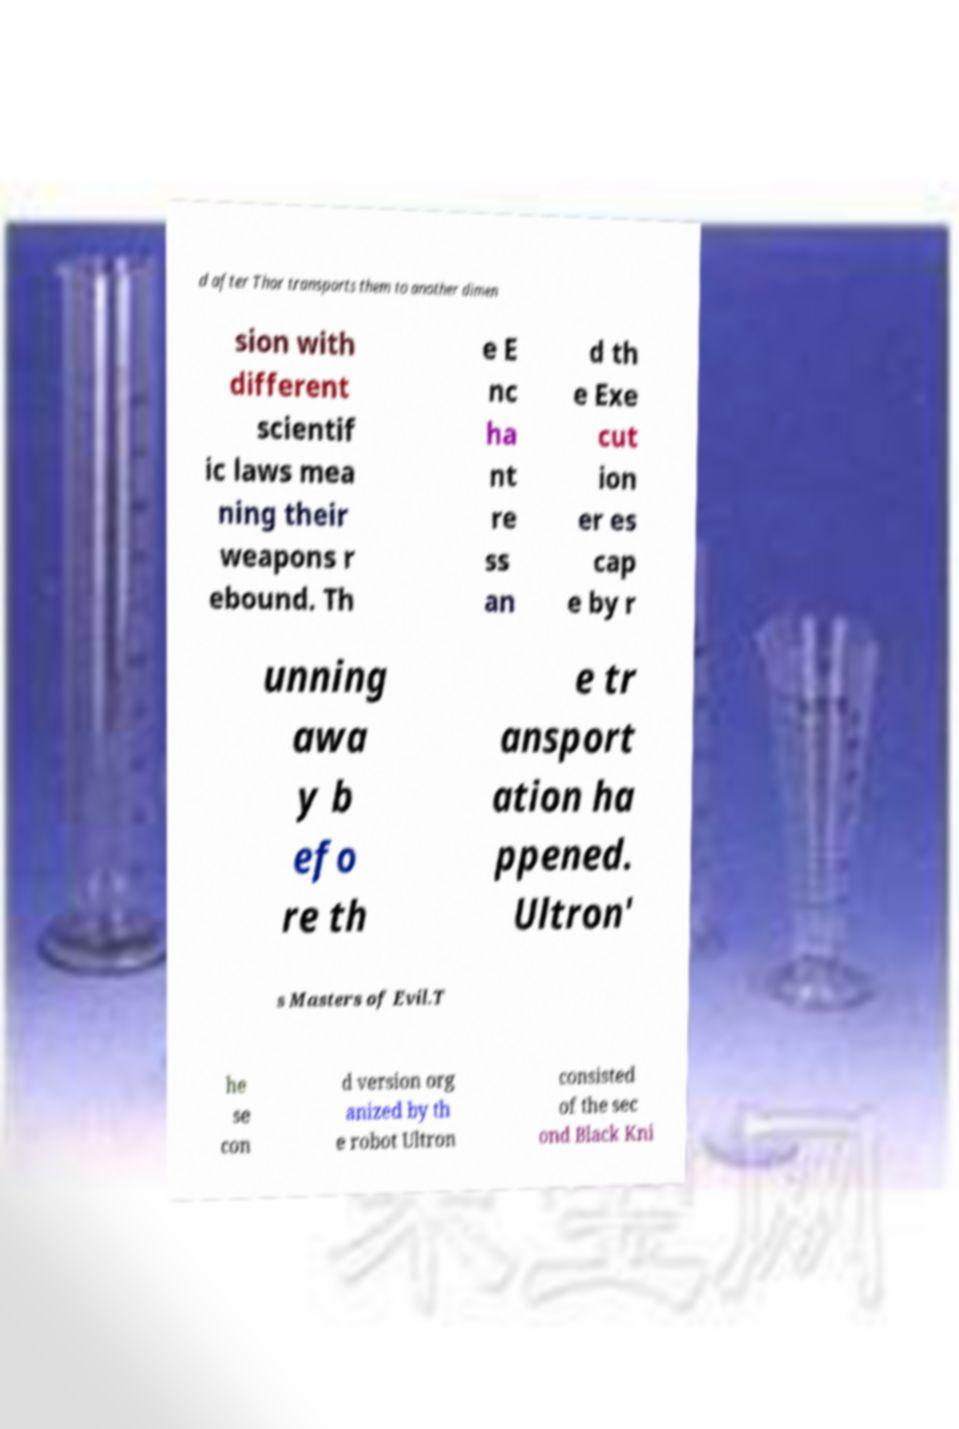What messages or text are displayed in this image? I need them in a readable, typed format. d after Thor transports them to another dimen sion with different scientif ic laws mea ning their weapons r ebound. Th e E nc ha nt re ss an d th e Exe cut ion er es cap e by r unning awa y b efo re th e tr ansport ation ha ppened. Ultron' s Masters of Evil.T he se con d version org anized by th e robot Ultron consisted of the sec ond Black Kni 